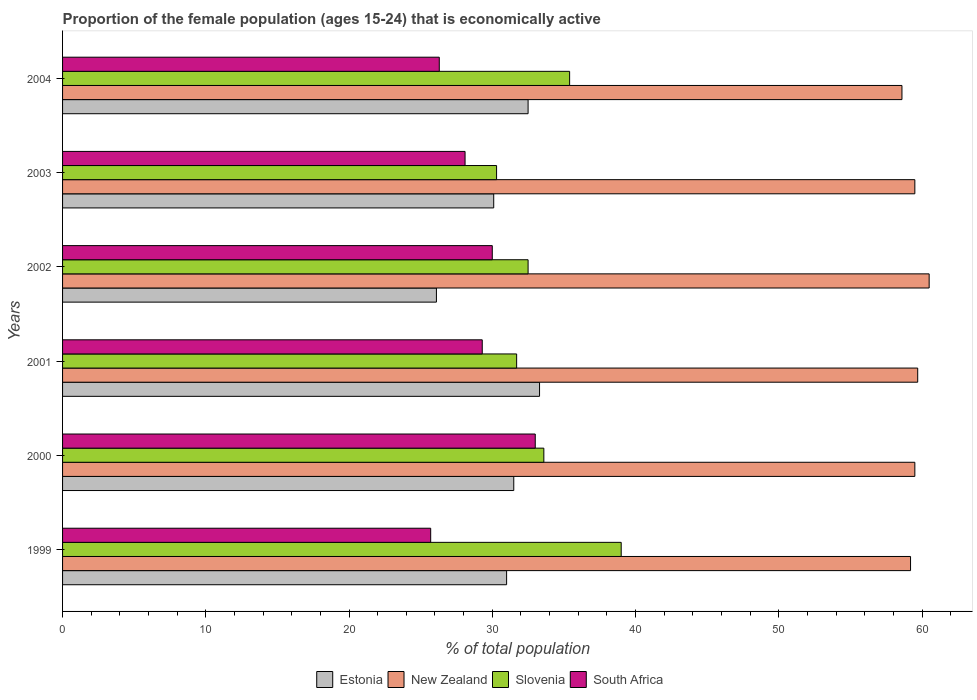Are the number of bars per tick equal to the number of legend labels?
Keep it short and to the point. Yes. What is the label of the 5th group of bars from the top?
Your response must be concise. 2000. In how many cases, is the number of bars for a given year not equal to the number of legend labels?
Your answer should be very brief. 0. What is the proportion of the female population that is economically active in Estonia in 2000?
Make the answer very short. 31.5. Across all years, what is the maximum proportion of the female population that is economically active in New Zealand?
Keep it short and to the point. 60.5. Across all years, what is the minimum proportion of the female population that is economically active in South Africa?
Your answer should be compact. 25.7. In which year was the proportion of the female population that is economically active in Slovenia maximum?
Offer a terse response. 1999. What is the total proportion of the female population that is economically active in Slovenia in the graph?
Provide a short and direct response. 202.5. What is the difference between the proportion of the female population that is economically active in South Africa in 2000 and that in 2002?
Provide a short and direct response. 3. What is the difference between the proportion of the female population that is economically active in Slovenia in 2000 and the proportion of the female population that is economically active in New Zealand in 1999?
Offer a terse response. -25.6. What is the average proportion of the female population that is economically active in South Africa per year?
Your answer should be compact. 28.73. In the year 2004, what is the difference between the proportion of the female population that is economically active in Estonia and proportion of the female population that is economically active in Slovenia?
Give a very brief answer. -2.9. What is the ratio of the proportion of the female population that is economically active in New Zealand in 2000 to that in 2002?
Make the answer very short. 0.98. Is the proportion of the female population that is economically active in Slovenia in 1999 less than that in 2001?
Provide a succinct answer. No. What is the difference between the highest and the second highest proportion of the female population that is economically active in Estonia?
Your answer should be very brief. 0.8. What is the difference between the highest and the lowest proportion of the female population that is economically active in South Africa?
Your answer should be very brief. 7.3. In how many years, is the proportion of the female population that is economically active in Estonia greater than the average proportion of the female population that is economically active in Estonia taken over all years?
Your answer should be very brief. 4. What does the 2nd bar from the top in 2000 represents?
Your response must be concise. Slovenia. What does the 2nd bar from the bottom in 2003 represents?
Your response must be concise. New Zealand. Are all the bars in the graph horizontal?
Keep it short and to the point. Yes. What is the difference between two consecutive major ticks on the X-axis?
Give a very brief answer. 10. Are the values on the major ticks of X-axis written in scientific E-notation?
Provide a short and direct response. No. Does the graph contain any zero values?
Offer a terse response. No. What is the title of the graph?
Ensure brevity in your answer.  Proportion of the female population (ages 15-24) that is economically active. Does "Congo (Republic)" appear as one of the legend labels in the graph?
Provide a short and direct response. No. What is the label or title of the X-axis?
Offer a very short reply. % of total population. What is the % of total population of New Zealand in 1999?
Make the answer very short. 59.2. What is the % of total population of Slovenia in 1999?
Make the answer very short. 39. What is the % of total population of South Africa in 1999?
Give a very brief answer. 25.7. What is the % of total population of Estonia in 2000?
Give a very brief answer. 31.5. What is the % of total population in New Zealand in 2000?
Ensure brevity in your answer.  59.5. What is the % of total population in Slovenia in 2000?
Provide a succinct answer. 33.6. What is the % of total population in Estonia in 2001?
Provide a succinct answer. 33.3. What is the % of total population in New Zealand in 2001?
Keep it short and to the point. 59.7. What is the % of total population in Slovenia in 2001?
Provide a short and direct response. 31.7. What is the % of total population in South Africa in 2001?
Give a very brief answer. 29.3. What is the % of total population of Estonia in 2002?
Make the answer very short. 26.1. What is the % of total population in New Zealand in 2002?
Give a very brief answer. 60.5. What is the % of total population in Slovenia in 2002?
Make the answer very short. 32.5. What is the % of total population of South Africa in 2002?
Keep it short and to the point. 30. What is the % of total population of Estonia in 2003?
Give a very brief answer. 30.1. What is the % of total population in New Zealand in 2003?
Give a very brief answer. 59.5. What is the % of total population of Slovenia in 2003?
Keep it short and to the point. 30.3. What is the % of total population in South Africa in 2003?
Make the answer very short. 28.1. What is the % of total population of Estonia in 2004?
Offer a terse response. 32.5. What is the % of total population of New Zealand in 2004?
Provide a succinct answer. 58.6. What is the % of total population in Slovenia in 2004?
Your answer should be very brief. 35.4. What is the % of total population in South Africa in 2004?
Make the answer very short. 26.3. Across all years, what is the maximum % of total population in Estonia?
Ensure brevity in your answer.  33.3. Across all years, what is the maximum % of total population in New Zealand?
Your answer should be very brief. 60.5. Across all years, what is the maximum % of total population in Slovenia?
Provide a short and direct response. 39. Across all years, what is the minimum % of total population of Estonia?
Ensure brevity in your answer.  26.1. Across all years, what is the minimum % of total population in New Zealand?
Your answer should be compact. 58.6. Across all years, what is the minimum % of total population in Slovenia?
Your answer should be very brief. 30.3. Across all years, what is the minimum % of total population in South Africa?
Provide a succinct answer. 25.7. What is the total % of total population of Estonia in the graph?
Offer a very short reply. 184.5. What is the total % of total population in New Zealand in the graph?
Offer a very short reply. 357. What is the total % of total population in Slovenia in the graph?
Give a very brief answer. 202.5. What is the total % of total population in South Africa in the graph?
Your answer should be very brief. 172.4. What is the difference between the % of total population in Estonia in 1999 and that in 2000?
Ensure brevity in your answer.  -0.5. What is the difference between the % of total population in South Africa in 1999 and that in 2000?
Offer a terse response. -7.3. What is the difference between the % of total population in Slovenia in 1999 and that in 2001?
Give a very brief answer. 7.3. What is the difference between the % of total population in Estonia in 1999 and that in 2002?
Keep it short and to the point. 4.9. What is the difference between the % of total population of Slovenia in 1999 and that in 2002?
Give a very brief answer. 6.5. What is the difference between the % of total population in South Africa in 1999 and that in 2002?
Offer a very short reply. -4.3. What is the difference between the % of total population of New Zealand in 1999 and that in 2003?
Your response must be concise. -0.3. What is the difference between the % of total population of Estonia in 1999 and that in 2004?
Keep it short and to the point. -1.5. What is the difference between the % of total population of Slovenia in 1999 and that in 2004?
Provide a succinct answer. 3.6. What is the difference between the % of total population in South Africa in 1999 and that in 2004?
Offer a terse response. -0.6. What is the difference between the % of total population in Estonia in 2000 and that in 2002?
Provide a short and direct response. 5.4. What is the difference between the % of total population in New Zealand in 2000 and that in 2002?
Provide a short and direct response. -1. What is the difference between the % of total population in New Zealand in 2000 and that in 2003?
Your answer should be compact. 0. What is the difference between the % of total population in South Africa in 2000 and that in 2003?
Your response must be concise. 4.9. What is the difference between the % of total population of Estonia in 2000 and that in 2004?
Your answer should be very brief. -1. What is the difference between the % of total population in New Zealand in 2000 and that in 2004?
Provide a short and direct response. 0.9. What is the difference between the % of total population in South Africa in 2000 and that in 2004?
Provide a short and direct response. 6.7. What is the difference between the % of total population of Estonia in 2001 and that in 2002?
Your answer should be compact. 7.2. What is the difference between the % of total population of New Zealand in 2001 and that in 2002?
Your answer should be very brief. -0.8. What is the difference between the % of total population of Slovenia in 2001 and that in 2002?
Offer a very short reply. -0.8. What is the difference between the % of total population in Slovenia in 2001 and that in 2004?
Your response must be concise. -3.7. What is the difference between the % of total population of South Africa in 2001 and that in 2004?
Your answer should be very brief. 3. What is the difference between the % of total population in New Zealand in 2002 and that in 2003?
Your answer should be very brief. 1. What is the difference between the % of total population in South Africa in 2002 and that in 2003?
Make the answer very short. 1.9. What is the difference between the % of total population of Estonia in 2002 and that in 2004?
Offer a very short reply. -6.4. What is the difference between the % of total population in New Zealand in 2002 and that in 2004?
Give a very brief answer. 1.9. What is the difference between the % of total population in South Africa in 2002 and that in 2004?
Provide a succinct answer. 3.7. What is the difference between the % of total population of Estonia in 2003 and that in 2004?
Ensure brevity in your answer.  -2.4. What is the difference between the % of total population in Slovenia in 2003 and that in 2004?
Keep it short and to the point. -5.1. What is the difference between the % of total population of South Africa in 2003 and that in 2004?
Your answer should be very brief. 1.8. What is the difference between the % of total population of Estonia in 1999 and the % of total population of New Zealand in 2000?
Your response must be concise. -28.5. What is the difference between the % of total population of Estonia in 1999 and the % of total population of Slovenia in 2000?
Provide a succinct answer. -2.6. What is the difference between the % of total population in Estonia in 1999 and the % of total population in South Africa in 2000?
Your response must be concise. -2. What is the difference between the % of total population of New Zealand in 1999 and the % of total population of Slovenia in 2000?
Make the answer very short. 25.6. What is the difference between the % of total population of New Zealand in 1999 and the % of total population of South Africa in 2000?
Provide a succinct answer. 26.2. What is the difference between the % of total population of Estonia in 1999 and the % of total population of New Zealand in 2001?
Your answer should be very brief. -28.7. What is the difference between the % of total population in Estonia in 1999 and the % of total population in Slovenia in 2001?
Your response must be concise. -0.7. What is the difference between the % of total population in Estonia in 1999 and the % of total population in South Africa in 2001?
Make the answer very short. 1.7. What is the difference between the % of total population of New Zealand in 1999 and the % of total population of Slovenia in 2001?
Your answer should be very brief. 27.5. What is the difference between the % of total population of New Zealand in 1999 and the % of total population of South Africa in 2001?
Keep it short and to the point. 29.9. What is the difference between the % of total population of Estonia in 1999 and the % of total population of New Zealand in 2002?
Provide a succinct answer. -29.5. What is the difference between the % of total population of Estonia in 1999 and the % of total population of South Africa in 2002?
Your answer should be compact. 1. What is the difference between the % of total population in New Zealand in 1999 and the % of total population in Slovenia in 2002?
Give a very brief answer. 26.7. What is the difference between the % of total population in New Zealand in 1999 and the % of total population in South Africa in 2002?
Make the answer very short. 29.2. What is the difference between the % of total population of Slovenia in 1999 and the % of total population of South Africa in 2002?
Your answer should be very brief. 9. What is the difference between the % of total population in Estonia in 1999 and the % of total population in New Zealand in 2003?
Make the answer very short. -28.5. What is the difference between the % of total population in New Zealand in 1999 and the % of total population in Slovenia in 2003?
Provide a short and direct response. 28.9. What is the difference between the % of total population of New Zealand in 1999 and the % of total population of South Africa in 2003?
Your response must be concise. 31.1. What is the difference between the % of total population in Estonia in 1999 and the % of total population in New Zealand in 2004?
Make the answer very short. -27.6. What is the difference between the % of total population of New Zealand in 1999 and the % of total population of Slovenia in 2004?
Keep it short and to the point. 23.8. What is the difference between the % of total population of New Zealand in 1999 and the % of total population of South Africa in 2004?
Offer a terse response. 32.9. What is the difference between the % of total population of Slovenia in 1999 and the % of total population of South Africa in 2004?
Offer a very short reply. 12.7. What is the difference between the % of total population in Estonia in 2000 and the % of total population in New Zealand in 2001?
Provide a succinct answer. -28.2. What is the difference between the % of total population in Estonia in 2000 and the % of total population in South Africa in 2001?
Your answer should be very brief. 2.2. What is the difference between the % of total population of New Zealand in 2000 and the % of total population of Slovenia in 2001?
Offer a very short reply. 27.8. What is the difference between the % of total population in New Zealand in 2000 and the % of total population in South Africa in 2001?
Your answer should be very brief. 30.2. What is the difference between the % of total population in Estonia in 2000 and the % of total population in New Zealand in 2002?
Keep it short and to the point. -29. What is the difference between the % of total population of Estonia in 2000 and the % of total population of Slovenia in 2002?
Provide a short and direct response. -1. What is the difference between the % of total population of Estonia in 2000 and the % of total population of South Africa in 2002?
Give a very brief answer. 1.5. What is the difference between the % of total population in New Zealand in 2000 and the % of total population in Slovenia in 2002?
Ensure brevity in your answer.  27. What is the difference between the % of total population in New Zealand in 2000 and the % of total population in South Africa in 2002?
Keep it short and to the point. 29.5. What is the difference between the % of total population in Slovenia in 2000 and the % of total population in South Africa in 2002?
Ensure brevity in your answer.  3.6. What is the difference between the % of total population in Estonia in 2000 and the % of total population in New Zealand in 2003?
Provide a short and direct response. -28. What is the difference between the % of total population in New Zealand in 2000 and the % of total population in Slovenia in 2003?
Keep it short and to the point. 29.2. What is the difference between the % of total population of New Zealand in 2000 and the % of total population of South Africa in 2003?
Offer a terse response. 31.4. What is the difference between the % of total population in Estonia in 2000 and the % of total population in New Zealand in 2004?
Keep it short and to the point. -27.1. What is the difference between the % of total population of New Zealand in 2000 and the % of total population of Slovenia in 2004?
Make the answer very short. 24.1. What is the difference between the % of total population in New Zealand in 2000 and the % of total population in South Africa in 2004?
Offer a terse response. 33.2. What is the difference between the % of total population of Slovenia in 2000 and the % of total population of South Africa in 2004?
Give a very brief answer. 7.3. What is the difference between the % of total population of Estonia in 2001 and the % of total population of New Zealand in 2002?
Your answer should be very brief. -27.2. What is the difference between the % of total population in Estonia in 2001 and the % of total population in South Africa in 2002?
Your response must be concise. 3.3. What is the difference between the % of total population of New Zealand in 2001 and the % of total population of Slovenia in 2002?
Provide a succinct answer. 27.2. What is the difference between the % of total population of New Zealand in 2001 and the % of total population of South Africa in 2002?
Give a very brief answer. 29.7. What is the difference between the % of total population in Estonia in 2001 and the % of total population in New Zealand in 2003?
Your answer should be very brief. -26.2. What is the difference between the % of total population in Estonia in 2001 and the % of total population in Slovenia in 2003?
Ensure brevity in your answer.  3. What is the difference between the % of total population of New Zealand in 2001 and the % of total population of Slovenia in 2003?
Ensure brevity in your answer.  29.4. What is the difference between the % of total population in New Zealand in 2001 and the % of total population in South Africa in 2003?
Provide a succinct answer. 31.6. What is the difference between the % of total population in Estonia in 2001 and the % of total population in New Zealand in 2004?
Keep it short and to the point. -25.3. What is the difference between the % of total population of Estonia in 2001 and the % of total population of Slovenia in 2004?
Give a very brief answer. -2.1. What is the difference between the % of total population in Estonia in 2001 and the % of total population in South Africa in 2004?
Your answer should be very brief. 7. What is the difference between the % of total population in New Zealand in 2001 and the % of total population in Slovenia in 2004?
Make the answer very short. 24.3. What is the difference between the % of total population in New Zealand in 2001 and the % of total population in South Africa in 2004?
Your answer should be compact. 33.4. What is the difference between the % of total population in Estonia in 2002 and the % of total population in New Zealand in 2003?
Give a very brief answer. -33.4. What is the difference between the % of total population in Estonia in 2002 and the % of total population in Slovenia in 2003?
Provide a short and direct response. -4.2. What is the difference between the % of total population of Estonia in 2002 and the % of total population of South Africa in 2003?
Offer a very short reply. -2. What is the difference between the % of total population in New Zealand in 2002 and the % of total population in Slovenia in 2003?
Your answer should be very brief. 30.2. What is the difference between the % of total population of New Zealand in 2002 and the % of total population of South Africa in 2003?
Provide a short and direct response. 32.4. What is the difference between the % of total population in Estonia in 2002 and the % of total population in New Zealand in 2004?
Keep it short and to the point. -32.5. What is the difference between the % of total population of Estonia in 2002 and the % of total population of Slovenia in 2004?
Your response must be concise. -9.3. What is the difference between the % of total population of Estonia in 2002 and the % of total population of South Africa in 2004?
Ensure brevity in your answer.  -0.2. What is the difference between the % of total population of New Zealand in 2002 and the % of total population of Slovenia in 2004?
Provide a short and direct response. 25.1. What is the difference between the % of total population of New Zealand in 2002 and the % of total population of South Africa in 2004?
Your response must be concise. 34.2. What is the difference between the % of total population of Estonia in 2003 and the % of total population of New Zealand in 2004?
Offer a very short reply. -28.5. What is the difference between the % of total population of Estonia in 2003 and the % of total population of South Africa in 2004?
Your answer should be compact. 3.8. What is the difference between the % of total population of New Zealand in 2003 and the % of total population of Slovenia in 2004?
Your answer should be very brief. 24.1. What is the difference between the % of total population of New Zealand in 2003 and the % of total population of South Africa in 2004?
Your answer should be very brief. 33.2. What is the average % of total population in Estonia per year?
Ensure brevity in your answer.  30.75. What is the average % of total population of New Zealand per year?
Your answer should be compact. 59.5. What is the average % of total population in Slovenia per year?
Ensure brevity in your answer.  33.75. What is the average % of total population of South Africa per year?
Keep it short and to the point. 28.73. In the year 1999, what is the difference between the % of total population of Estonia and % of total population of New Zealand?
Your answer should be compact. -28.2. In the year 1999, what is the difference between the % of total population of Estonia and % of total population of South Africa?
Offer a very short reply. 5.3. In the year 1999, what is the difference between the % of total population of New Zealand and % of total population of Slovenia?
Keep it short and to the point. 20.2. In the year 1999, what is the difference between the % of total population in New Zealand and % of total population in South Africa?
Provide a succinct answer. 33.5. In the year 1999, what is the difference between the % of total population of Slovenia and % of total population of South Africa?
Keep it short and to the point. 13.3. In the year 2000, what is the difference between the % of total population in New Zealand and % of total population in Slovenia?
Offer a terse response. 25.9. In the year 2000, what is the difference between the % of total population of New Zealand and % of total population of South Africa?
Offer a terse response. 26.5. In the year 2000, what is the difference between the % of total population in Slovenia and % of total population in South Africa?
Your answer should be compact. 0.6. In the year 2001, what is the difference between the % of total population in Estonia and % of total population in New Zealand?
Your response must be concise. -26.4. In the year 2001, what is the difference between the % of total population of New Zealand and % of total population of Slovenia?
Keep it short and to the point. 28. In the year 2001, what is the difference between the % of total population of New Zealand and % of total population of South Africa?
Provide a succinct answer. 30.4. In the year 2001, what is the difference between the % of total population in Slovenia and % of total population in South Africa?
Provide a short and direct response. 2.4. In the year 2002, what is the difference between the % of total population of Estonia and % of total population of New Zealand?
Provide a succinct answer. -34.4. In the year 2002, what is the difference between the % of total population in Estonia and % of total population in Slovenia?
Your answer should be very brief. -6.4. In the year 2002, what is the difference between the % of total population in New Zealand and % of total population in Slovenia?
Offer a terse response. 28. In the year 2002, what is the difference between the % of total population in New Zealand and % of total population in South Africa?
Your answer should be compact. 30.5. In the year 2003, what is the difference between the % of total population of Estonia and % of total population of New Zealand?
Give a very brief answer. -29.4. In the year 2003, what is the difference between the % of total population in Estonia and % of total population in Slovenia?
Ensure brevity in your answer.  -0.2. In the year 2003, what is the difference between the % of total population of New Zealand and % of total population of Slovenia?
Your response must be concise. 29.2. In the year 2003, what is the difference between the % of total population of New Zealand and % of total population of South Africa?
Offer a very short reply. 31.4. In the year 2004, what is the difference between the % of total population of Estonia and % of total population of New Zealand?
Provide a short and direct response. -26.1. In the year 2004, what is the difference between the % of total population in Estonia and % of total population in South Africa?
Give a very brief answer. 6.2. In the year 2004, what is the difference between the % of total population of New Zealand and % of total population of Slovenia?
Your response must be concise. 23.2. In the year 2004, what is the difference between the % of total population in New Zealand and % of total population in South Africa?
Your answer should be compact. 32.3. What is the ratio of the % of total population of Estonia in 1999 to that in 2000?
Your answer should be very brief. 0.98. What is the ratio of the % of total population in New Zealand in 1999 to that in 2000?
Offer a very short reply. 0.99. What is the ratio of the % of total population in Slovenia in 1999 to that in 2000?
Make the answer very short. 1.16. What is the ratio of the % of total population of South Africa in 1999 to that in 2000?
Ensure brevity in your answer.  0.78. What is the ratio of the % of total population of Estonia in 1999 to that in 2001?
Offer a very short reply. 0.93. What is the ratio of the % of total population in Slovenia in 1999 to that in 2001?
Keep it short and to the point. 1.23. What is the ratio of the % of total population of South Africa in 1999 to that in 2001?
Keep it short and to the point. 0.88. What is the ratio of the % of total population in Estonia in 1999 to that in 2002?
Give a very brief answer. 1.19. What is the ratio of the % of total population of New Zealand in 1999 to that in 2002?
Your response must be concise. 0.98. What is the ratio of the % of total population in South Africa in 1999 to that in 2002?
Your response must be concise. 0.86. What is the ratio of the % of total population of Estonia in 1999 to that in 2003?
Your answer should be compact. 1.03. What is the ratio of the % of total population in New Zealand in 1999 to that in 2003?
Your answer should be very brief. 0.99. What is the ratio of the % of total population of Slovenia in 1999 to that in 2003?
Your response must be concise. 1.29. What is the ratio of the % of total population in South Africa in 1999 to that in 2003?
Provide a short and direct response. 0.91. What is the ratio of the % of total population in Estonia in 1999 to that in 2004?
Make the answer very short. 0.95. What is the ratio of the % of total population of New Zealand in 1999 to that in 2004?
Provide a succinct answer. 1.01. What is the ratio of the % of total population of Slovenia in 1999 to that in 2004?
Provide a succinct answer. 1.1. What is the ratio of the % of total population of South Africa in 1999 to that in 2004?
Provide a succinct answer. 0.98. What is the ratio of the % of total population of Estonia in 2000 to that in 2001?
Make the answer very short. 0.95. What is the ratio of the % of total population of Slovenia in 2000 to that in 2001?
Your answer should be very brief. 1.06. What is the ratio of the % of total population of South Africa in 2000 to that in 2001?
Your answer should be compact. 1.13. What is the ratio of the % of total population in Estonia in 2000 to that in 2002?
Make the answer very short. 1.21. What is the ratio of the % of total population in New Zealand in 2000 to that in 2002?
Provide a succinct answer. 0.98. What is the ratio of the % of total population of Slovenia in 2000 to that in 2002?
Your response must be concise. 1.03. What is the ratio of the % of total population of Estonia in 2000 to that in 2003?
Ensure brevity in your answer.  1.05. What is the ratio of the % of total population in New Zealand in 2000 to that in 2003?
Provide a succinct answer. 1. What is the ratio of the % of total population in Slovenia in 2000 to that in 2003?
Your answer should be very brief. 1.11. What is the ratio of the % of total population of South Africa in 2000 to that in 2003?
Keep it short and to the point. 1.17. What is the ratio of the % of total population in Estonia in 2000 to that in 2004?
Provide a succinct answer. 0.97. What is the ratio of the % of total population in New Zealand in 2000 to that in 2004?
Give a very brief answer. 1.02. What is the ratio of the % of total population of Slovenia in 2000 to that in 2004?
Provide a short and direct response. 0.95. What is the ratio of the % of total population in South Africa in 2000 to that in 2004?
Your answer should be compact. 1.25. What is the ratio of the % of total population of Estonia in 2001 to that in 2002?
Provide a short and direct response. 1.28. What is the ratio of the % of total population in New Zealand in 2001 to that in 2002?
Ensure brevity in your answer.  0.99. What is the ratio of the % of total population in Slovenia in 2001 to that in 2002?
Your response must be concise. 0.98. What is the ratio of the % of total population of South Africa in 2001 to that in 2002?
Give a very brief answer. 0.98. What is the ratio of the % of total population in Estonia in 2001 to that in 2003?
Ensure brevity in your answer.  1.11. What is the ratio of the % of total population of Slovenia in 2001 to that in 2003?
Your answer should be compact. 1.05. What is the ratio of the % of total population of South Africa in 2001 to that in 2003?
Offer a terse response. 1.04. What is the ratio of the % of total population of Estonia in 2001 to that in 2004?
Make the answer very short. 1.02. What is the ratio of the % of total population of New Zealand in 2001 to that in 2004?
Keep it short and to the point. 1.02. What is the ratio of the % of total population of Slovenia in 2001 to that in 2004?
Provide a short and direct response. 0.9. What is the ratio of the % of total population of South Africa in 2001 to that in 2004?
Provide a short and direct response. 1.11. What is the ratio of the % of total population of Estonia in 2002 to that in 2003?
Ensure brevity in your answer.  0.87. What is the ratio of the % of total population of New Zealand in 2002 to that in 2003?
Your answer should be very brief. 1.02. What is the ratio of the % of total population of Slovenia in 2002 to that in 2003?
Your response must be concise. 1.07. What is the ratio of the % of total population in South Africa in 2002 to that in 2003?
Make the answer very short. 1.07. What is the ratio of the % of total population in Estonia in 2002 to that in 2004?
Ensure brevity in your answer.  0.8. What is the ratio of the % of total population of New Zealand in 2002 to that in 2004?
Your answer should be very brief. 1.03. What is the ratio of the % of total population of Slovenia in 2002 to that in 2004?
Make the answer very short. 0.92. What is the ratio of the % of total population in South Africa in 2002 to that in 2004?
Provide a succinct answer. 1.14. What is the ratio of the % of total population of Estonia in 2003 to that in 2004?
Your answer should be compact. 0.93. What is the ratio of the % of total population in New Zealand in 2003 to that in 2004?
Keep it short and to the point. 1.02. What is the ratio of the % of total population of Slovenia in 2003 to that in 2004?
Keep it short and to the point. 0.86. What is the ratio of the % of total population of South Africa in 2003 to that in 2004?
Your answer should be very brief. 1.07. What is the difference between the highest and the second highest % of total population in Estonia?
Give a very brief answer. 0.8. What is the difference between the highest and the second highest % of total population of Slovenia?
Your answer should be compact. 3.6. What is the difference between the highest and the second highest % of total population of South Africa?
Your response must be concise. 3. What is the difference between the highest and the lowest % of total population in Estonia?
Offer a very short reply. 7.2. What is the difference between the highest and the lowest % of total population of New Zealand?
Your response must be concise. 1.9. What is the difference between the highest and the lowest % of total population in Slovenia?
Keep it short and to the point. 8.7. What is the difference between the highest and the lowest % of total population of South Africa?
Your answer should be compact. 7.3. 